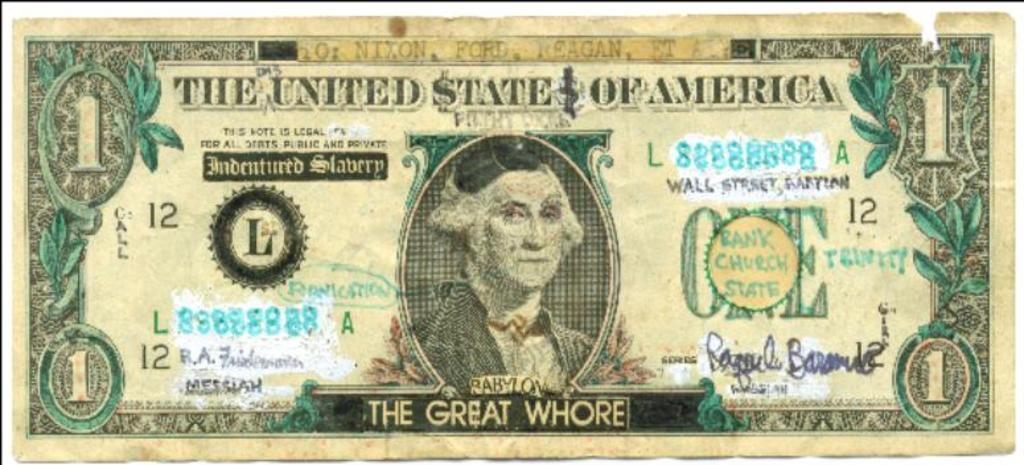What is the main object in the image? There is a currency note in the image. What is depicted on the currency note? The currency note has a person and leaves depicted on it. Are there any words on the currency note? Yes, there is text on the currency note. What type of industry can be seen in the background of the image? There is no industry visible in the image; it only features a currency note. Is there a slope present in the image? There is no slope present in the image; it only features a currency note. 